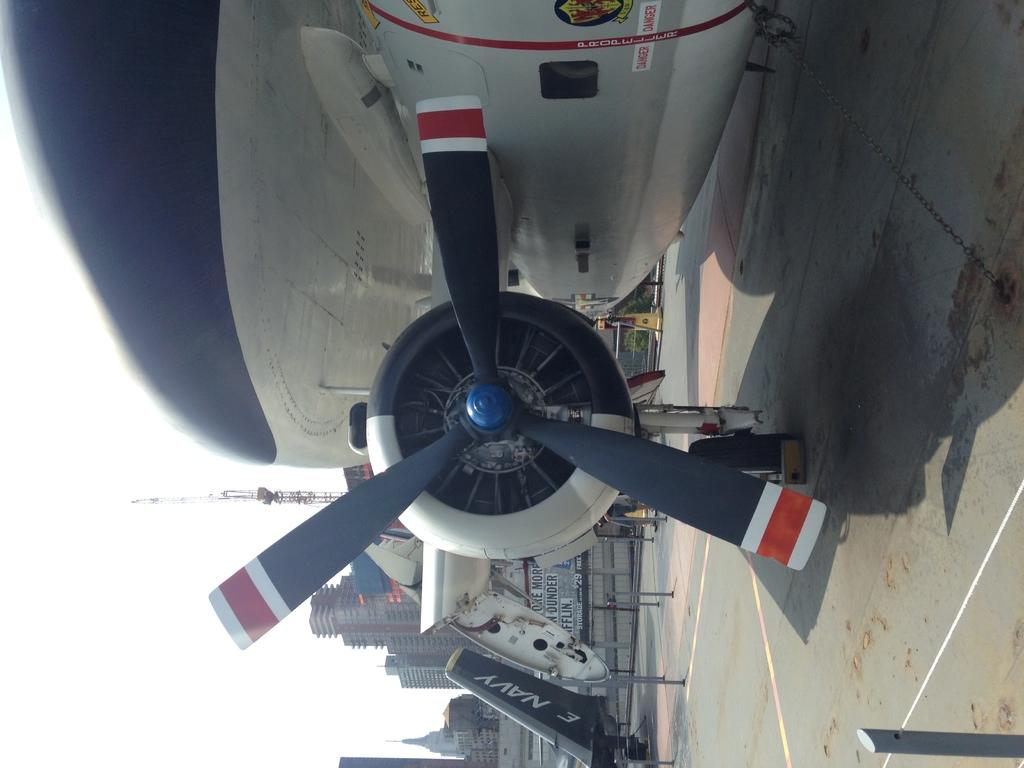<image>
Write a terse but informative summary of the picture. The plane in the background is part of a navy plane. 